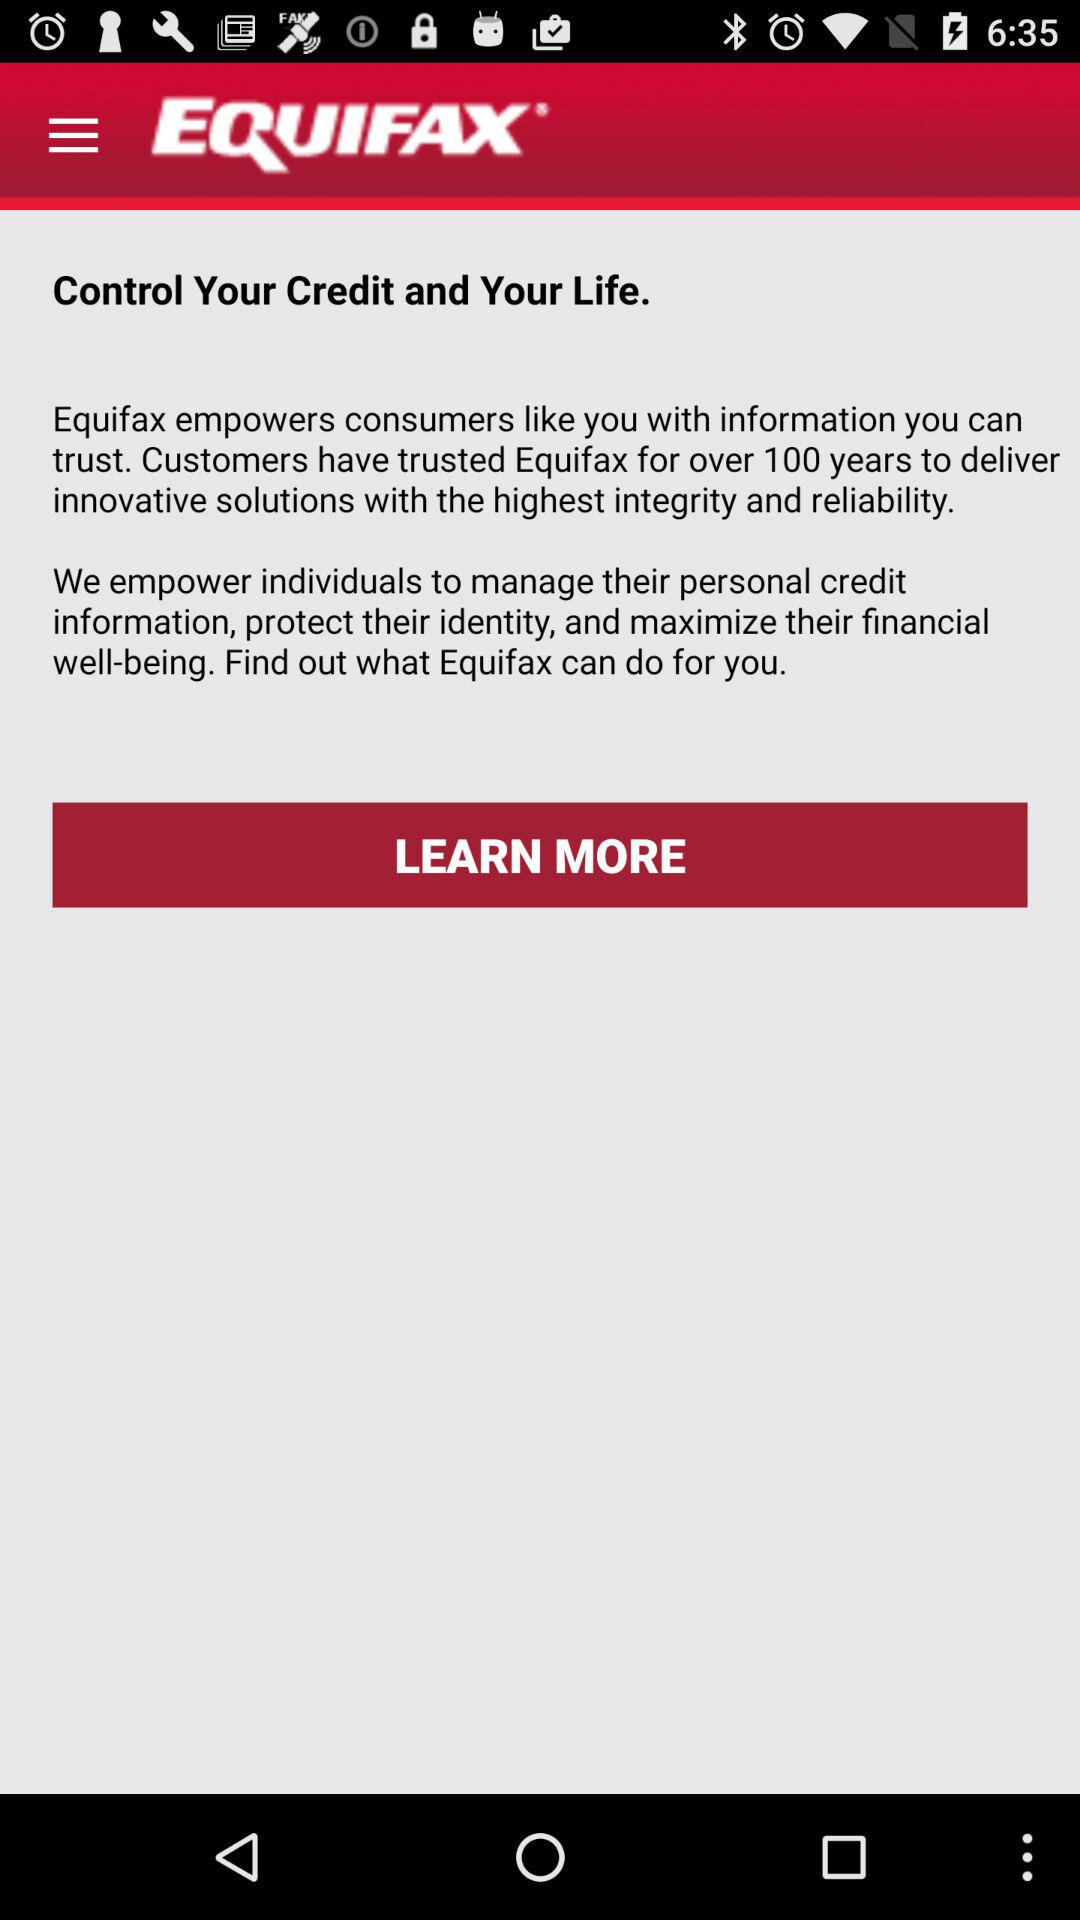What does "Equifax" empower individuals to manage? "Equifax" empowers individuals to manage their personal credit information. 